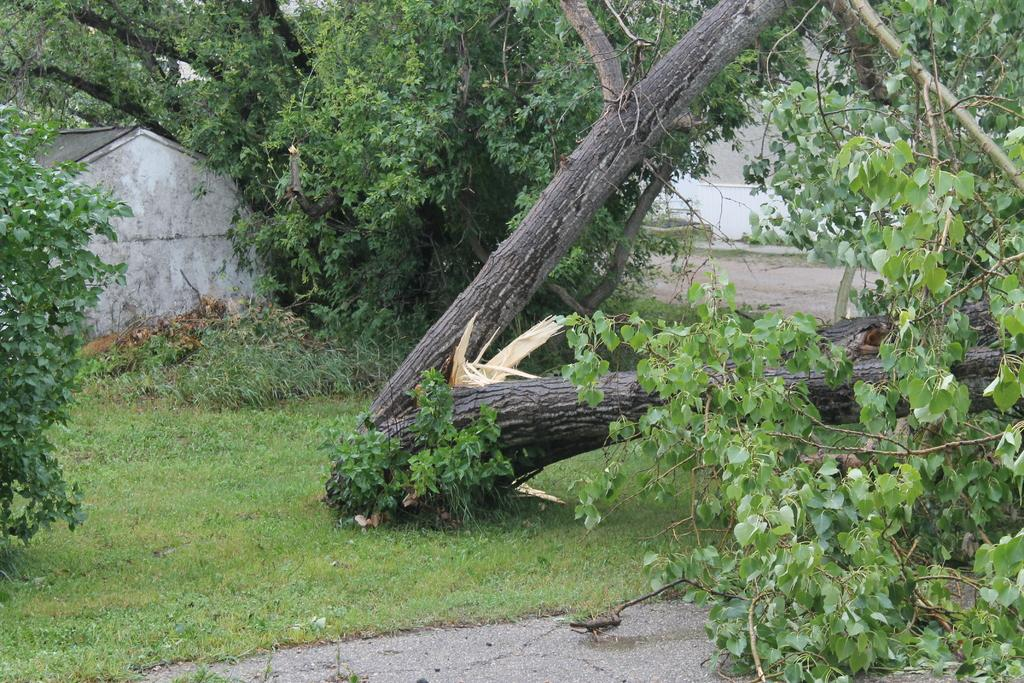What type of vegetation is visible in the image? There is grass, trees, and plants visible in the image. Can you describe the natural setting in the image? The natural setting includes grass, trees, and plants. Who is the owner of the knife in the image? There is no knife present in the image. What arithmetic problem can be solved using the plants in the image? The plants in the image are not related to arithmetic problems; they are simply part of the natural setting. 